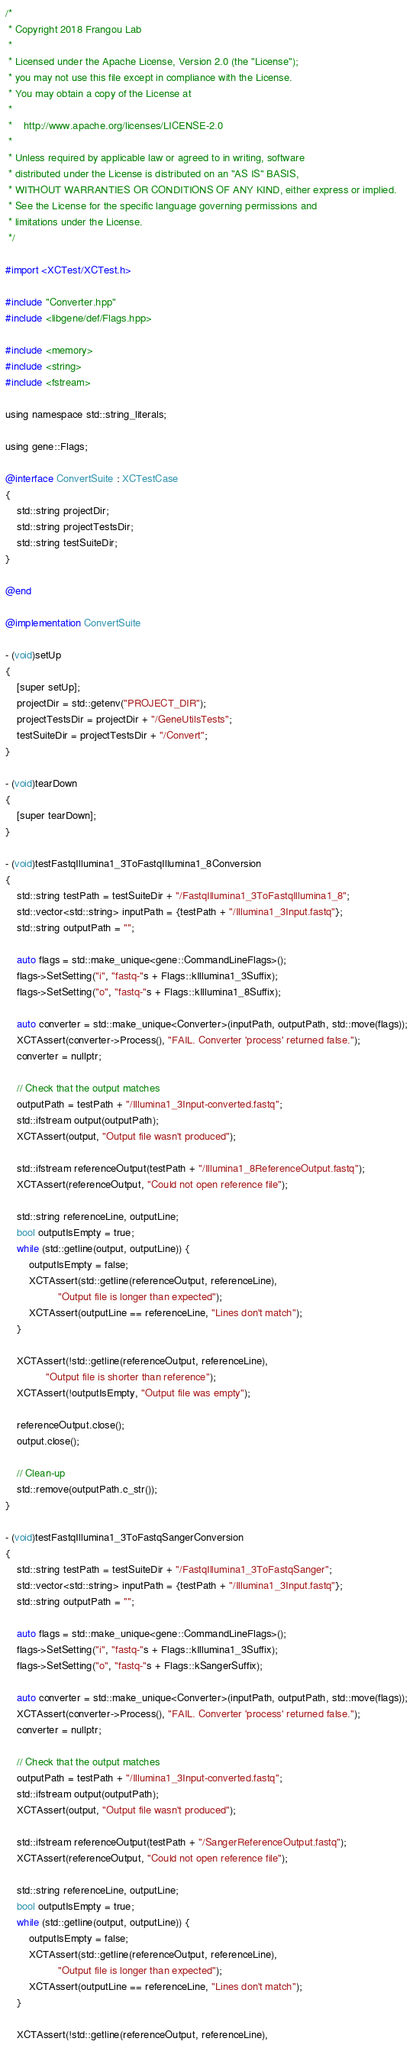<code> <loc_0><loc_0><loc_500><loc_500><_ObjectiveC_>/*
 * Copyright 2018 Frangou Lab
 *
 * Licensed under the Apache License, Version 2.0 (the "License");
 * you may not use this file except in compliance with the License.
 * You may obtain a copy of the License at
 *
 *    http://www.apache.org/licenses/LICENSE-2.0
 *
 * Unless required by applicable law or agreed to in writing, software
 * distributed under the License is distributed on an "AS IS" BASIS,
 * WITHOUT WARRANTIES OR CONDITIONS OF ANY KIND, either express or implied.
 * See the License for the specific language governing permissions and
 * limitations under the License.
 */

#import <XCTest/XCTest.h>

#include "Converter.hpp"
#include <libgene/def/Flags.hpp>

#include <memory>
#include <string>
#include <fstream>

using namespace std::string_literals;

using gene::Flags;

@interface ConvertSuite : XCTestCase
{
    std::string projectDir;
    std::string projectTestsDir;
    std::string testSuiteDir;
}

@end

@implementation ConvertSuite

- (void)setUp
{
    [super setUp];
    projectDir = std::getenv("PROJECT_DIR");
    projectTestsDir = projectDir + "/GeneUtilsTests";
    testSuiteDir = projectTestsDir + "/Convert";
}

- (void)tearDown
{
    [super tearDown];
}

- (void)testFastqIllumina1_3ToFastqIllumina1_8Conversion
{
    std::string testPath = testSuiteDir + "/FastqIllumina1_3ToFastqIllumina1_8";
    std::vector<std::string> inputPath = {testPath + "/Illumina1_3Input.fastq"};
    std::string outputPath = "";
    
    auto flags = std::make_unique<gene::CommandLineFlags>();
    flags->SetSetting("i", "fastq-"s + Flags::kIllumina1_3Suffix);
    flags->SetSetting("o", "fastq-"s + Flags::kIllumina1_8Suffix);
    
    auto converter = std::make_unique<Converter>(inputPath, outputPath, std::move(flags));
    XCTAssert(converter->Process(), "FAIL. Converter 'process' returned false.");
    converter = nullptr;
    
    // Check that the output matches
    outputPath = testPath + "/Illumina1_3Input-converted.fastq";
    std::ifstream output(outputPath);
    XCTAssert(output, "Output file wasn't produced");
    
    std::ifstream referenceOutput(testPath + "/Illumina1_8ReferenceOutput.fastq");
    XCTAssert(referenceOutput, "Could not open reference file");
    
    std::string referenceLine, outputLine;
    bool outputIsEmpty = true;
    while (std::getline(output, outputLine)) {
        outputIsEmpty = false;
        XCTAssert(std::getline(referenceOutput, referenceLine),
                  "Output file is longer than expected");
        XCTAssert(outputLine == referenceLine, "Lines don't match");
    }
    
    XCTAssert(!std::getline(referenceOutput, referenceLine),
              "Output file is shorter than reference");
    XCTAssert(!outputIsEmpty, "Output file was empty");
    
    referenceOutput.close();
    output.close();
    
    // Clean-up
    std::remove(outputPath.c_str());
}

- (void)testFastqIllumina1_3ToFastqSangerConversion
{
    std::string testPath = testSuiteDir + "/FastqIllumina1_3ToFastqSanger";
    std::vector<std::string> inputPath = {testPath + "/Illumina1_3Input.fastq"};
    std::string outputPath = "";
    
    auto flags = std::make_unique<gene::CommandLineFlags>();
    flags->SetSetting("i", "fastq-"s + Flags::kIllumina1_3Suffix);
    flags->SetSetting("o", "fastq-"s + Flags::kSangerSuffix);
    
    auto converter = std::make_unique<Converter>(inputPath, outputPath, std::move(flags));
    XCTAssert(converter->Process(), "FAIL. Converter 'process' returned false.");
    converter = nullptr;
    
    // Check that the output matches
    outputPath = testPath + "/Illumina1_3Input-converted.fastq";
    std::ifstream output(outputPath);
    XCTAssert(output, "Output file wasn't produced");
    
    std::ifstream referenceOutput(testPath + "/SangerReferenceOutput.fastq");
    XCTAssert(referenceOutput, "Could not open reference file");
    
    std::string referenceLine, outputLine;
    bool outputIsEmpty = true;
    while (std::getline(output, outputLine)) {
        outputIsEmpty = false;
        XCTAssert(std::getline(referenceOutput, referenceLine),
                  "Output file is longer than expected");
        XCTAssert(outputLine == referenceLine, "Lines don't match");
    }
    
    XCTAssert(!std::getline(referenceOutput, referenceLine),</code> 